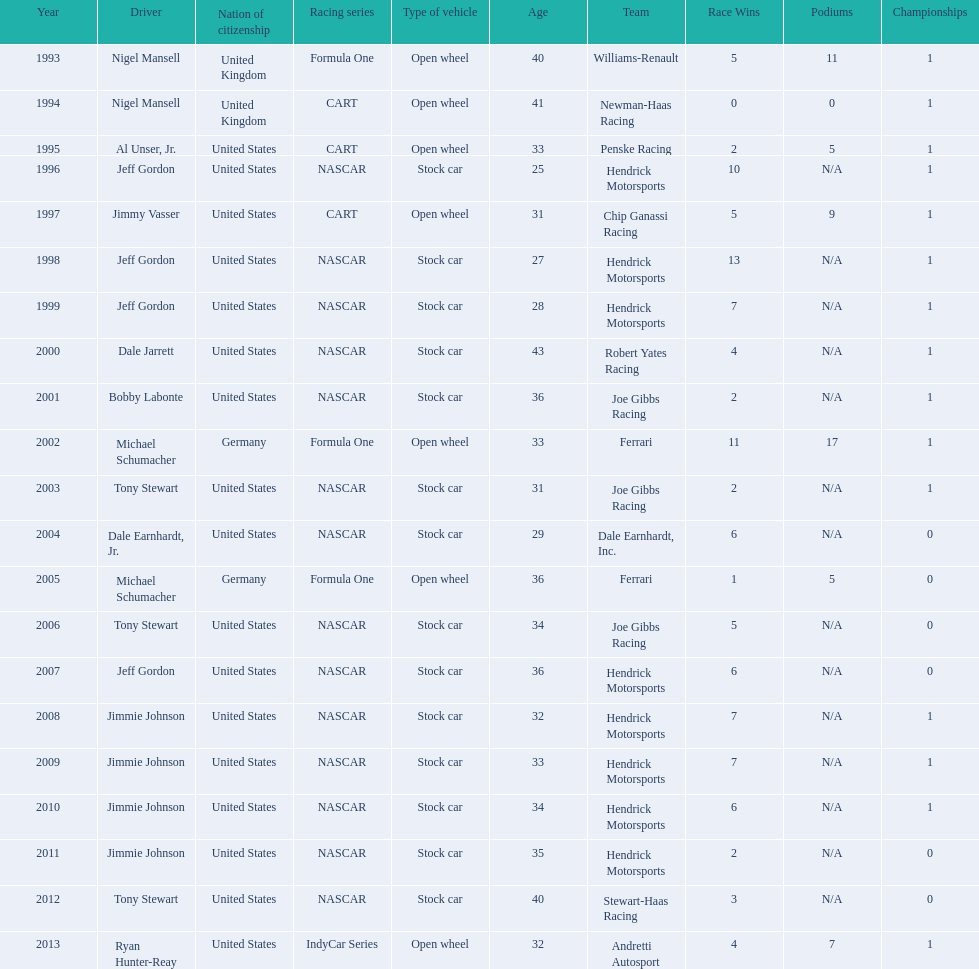Which drivers have won the best driver espy award? Nigel Mansell, Nigel Mansell, Al Unser, Jr., Jeff Gordon, Jimmy Vasser, Jeff Gordon, Jeff Gordon, Dale Jarrett, Bobby Labonte, Michael Schumacher, Tony Stewart, Dale Earnhardt, Jr., Michael Schumacher, Tony Stewart, Jeff Gordon, Jimmie Johnson, Jimmie Johnson, Jimmie Johnson, Jimmie Johnson, Tony Stewart, Ryan Hunter-Reay. Of these, which only appear once? Al Unser, Jr., Jimmy Vasser, Dale Jarrett, Dale Earnhardt, Jr., Ryan Hunter-Reay. Which of these are from the cart racing series? Al Unser, Jr., Jimmy Vasser. Of these, which received their award first? Al Unser, Jr. 